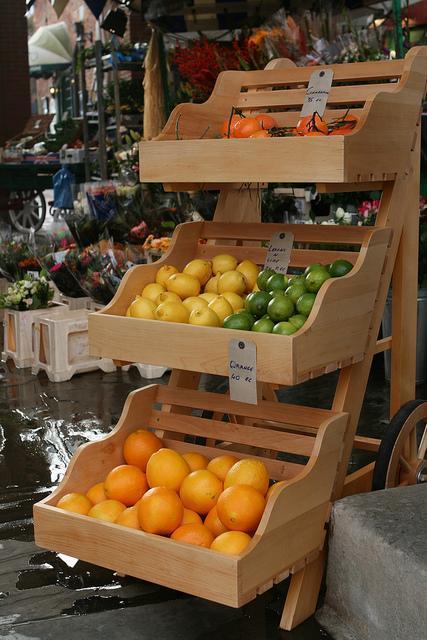The fruits in the raised wooden baskets seen here are all what?
Pick the right solution, then justify: 'Answer: answer
Rationale: rationale.'
Options: Citrus, apples, cherries, melons. Answer: citrus.
Rationale: They're oranges. 